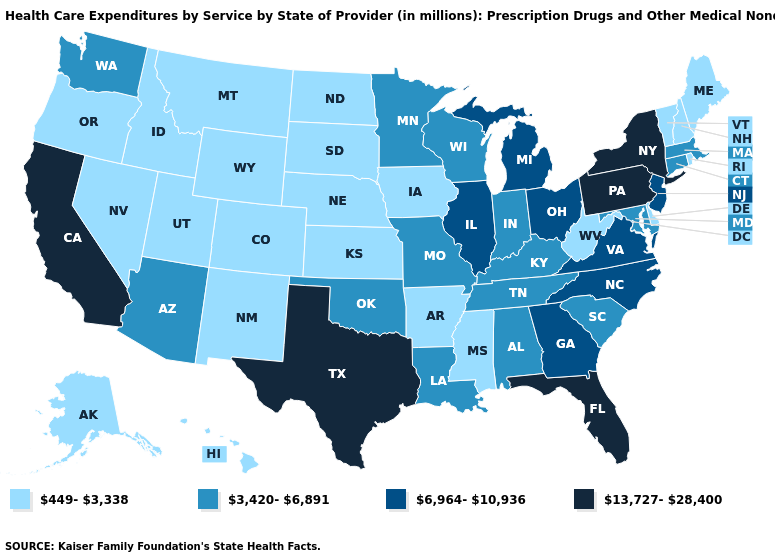Does New York have the highest value in the USA?
Be succinct. Yes. Which states hav the highest value in the MidWest?
Be succinct. Illinois, Michigan, Ohio. Among the states that border Louisiana , does Mississippi have the highest value?
Write a very short answer. No. What is the value of Indiana?
Answer briefly. 3,420-6,891. Does New Mexico have the same value as Alaska?
Keep it brief. Yes. What is the lowest value in the South?
Be succinct. 449-3,338. Does Florida have the highest value in the USA?
Give a very brief answer. Yes. Name the states that have a value in the range 449-3,338?
Short answer required. Alaska, Arkansas, Colorado, Delaware, Hawaii, Idaho, Iowa, Kansas, Maine, Mississippi, Montana, Nebraska, Nevada, New Hampshire, New Mexico, North Dakota, Oregon, Rhode Island, South Dakota, Utah, Vermont, West Virginia, Wyoming. What is the value of Iowa?
Concise answer only. 449-3,338. What is the highest value in the Northeast ?
Write a very short answer. 13,727-28,400. Does Texas have the highest value in the USA?
Concise answer only. Yes. What is the value of West Virginia?
Short answer required. 449-3,338. Does Hawaii have the lowest value in the USA?
Keep it brief. Yes. Is the legend a continuous bar?
Concise answer only. No. What is the value of North Carolina?
Short answer required. 6,964-10,936. 